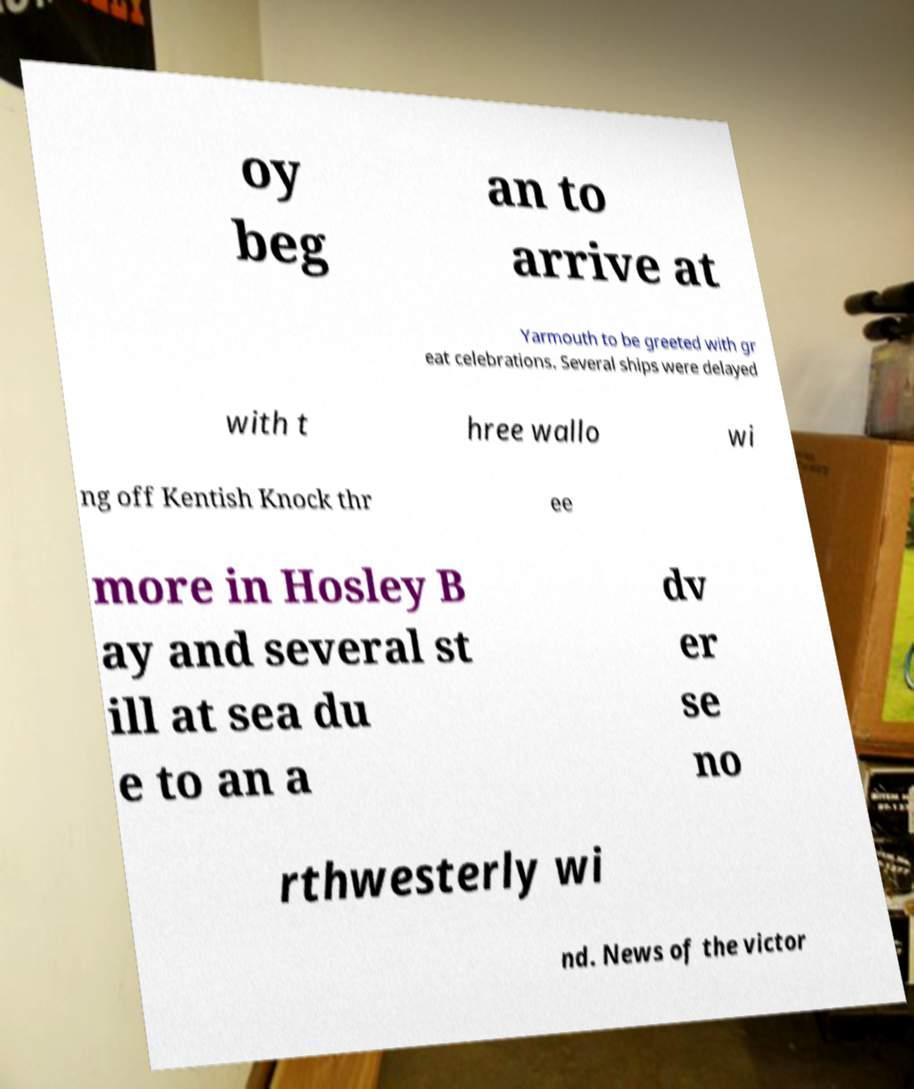What messages or text are displayed in this image? I need them in a readable, typed format. oy beg an to arrive at Yarmouth to be greeted with gr eat celebrations. Several ships were delayed with t hree wallo wi ng off Kentish Knock thr ee more in Hosley B ay and several st ill at sea du e to an a dv er se no rthwesterly wi nd. News of the victor 